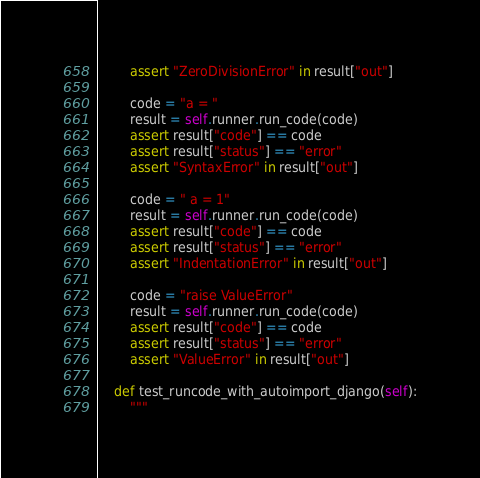<code> <loc_0><loc_0><loc_500><loc_500><_Python_>        assert "ZeroDivisionError" in result["out"]

        code = "a = "
        result = self.runner.run_code(code)
        assert result["code"] == code
        assert result["status"] == "error"
        assert "SyntaxError" in result["out"]

        code = " a = 1"
        result = self.runner.run_code(code)
        assert result["code"] == code
        assert result["status"] == "error"
        assert "IndentationError" in result["out"]

        code = "raise ValueError"
        result = self.runner.run_code(code)
        assert result["code"] == code
        assert result["status"] == "error"
        assert "ValueError" in result["out"]

    def test_runcode_with_autoimport_django(self):
        """</code> 